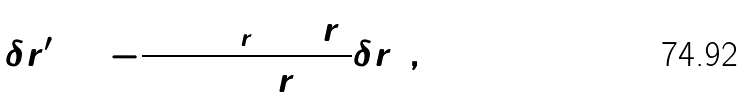Convert formula to latex. <formula><loc_0><loc_0><loc_500><loc_500>\delta r _ { 1 } ^ { \prime } = - \frac { 9 + \Omega _ { r } + 3 r _ { 2 } } { 2 ( 1 + r _ { 2 } ) } \delta r _ { 1 } \, ,</formula> 